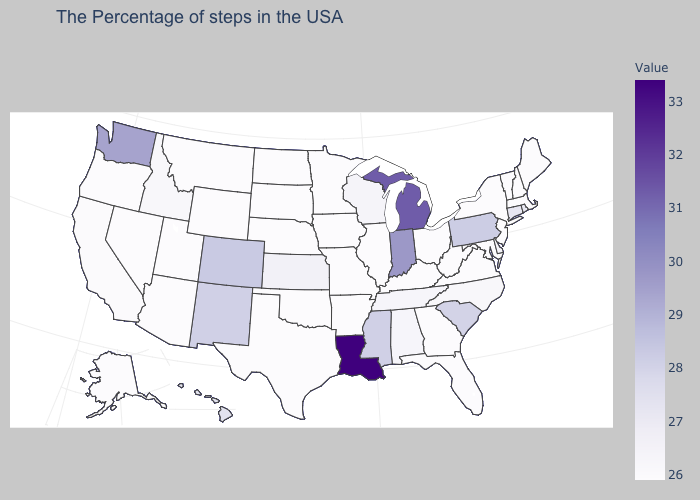Which states have the lowest value in the USA?
Short answer required. Maine, Massachusetts, New Hampshire, Vermont, New York, New Jersey, Maryland, Virginia, West Virginia, Ohio, Florida, Georgia, Kentucky, Illinois, Missouri, Arkansas, Minnesota, Iowa, Nebraska, Oklahoma, Texas, South Dakota, North Dakota, Wyoming, Utah, Montana, Arizona, Nevada, Oregon, Alaska. Which states have the lowest value in the USA?
Be succinct. Maine, Massachusetts, New Hampshire, Vermont, New York, New Jersey, Maryland, Virginia, West Virginia, Ohio, Florida, Georgia, Kentucky, Illinois, Missouri, Arkansas, Minnesota, Iowa, Nebraska, Oklahoma, Texas, South Dakota, North Dakota, Wyoming, Utah, Montana, Arizona, Nevada, Oregon, Alaska. Among the states that border Louisiana , which have the highest value?
Concise answer only. Mississippi. Does Delaware have a lower value than New Mexico?
Quick response, please. Yes. 